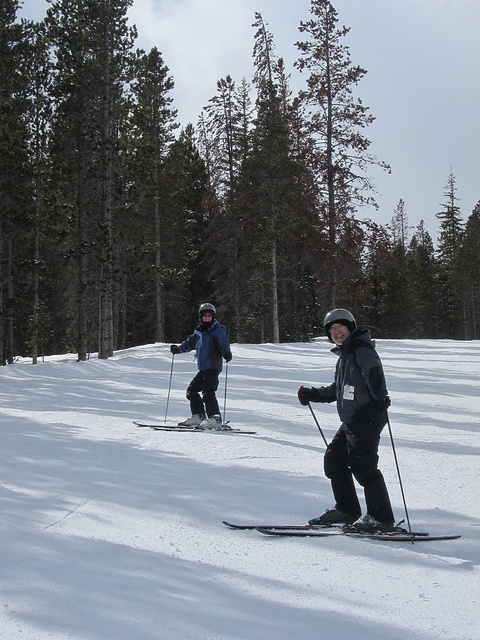Describe the objects in this image and their specific colors. I can see people in black, gray, and darkgray tones, people in black, navy, gray, and darkgray tones, skis in black, darkgray, and gray tones, and skis in black, darkgray, lightgray, and gray tones in this image. 